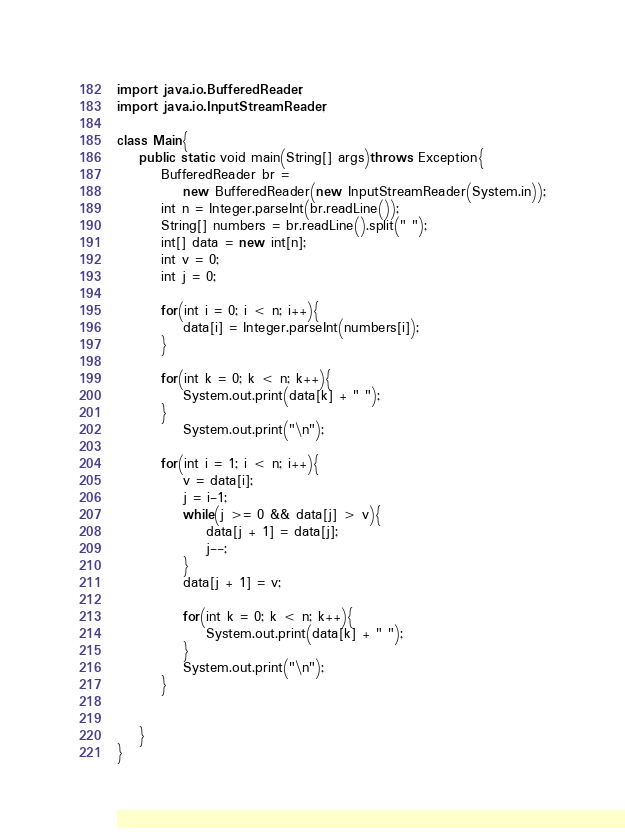<code> <loc_0><loc_0><loc_500><loc_500><_Java_>import java.io.BufferedReader;
import java.io.InputStreamReader;

class Main{
	public static void main(String[] args)throws Exception{
		BufferedReader br = 
			new BufferedReader(new InputStreamReader(System.in));
		int n = Integer.parseInt(br.readLine());
		String[] numbers = br.readLine().split(" ");
		int[] data = new int[n];
		int v = 0;
		int j = 0;
		
		for(int i = 0; i < n; i++){
			data[i] = Integer.parseInt(numbers[i]);
		}
		
		for(int k = 0; k < n; k++){
			System.out.print(data[k] + " ");
		}
			System.out.print("\n");

		for(int i = 1; i < n; i++){
			v = data[i];
			j = i-1;
			while(j >= 0 && data[j] > v){
				data[j + 1] = data[j];
				j--;
			}
			data[j + 1] = v;

			for(int k = 0; k < n; k++){
				System.out.print(data[k] + " ");
			}
			System.out.print("\n");
		}

		
	}
}</code> 